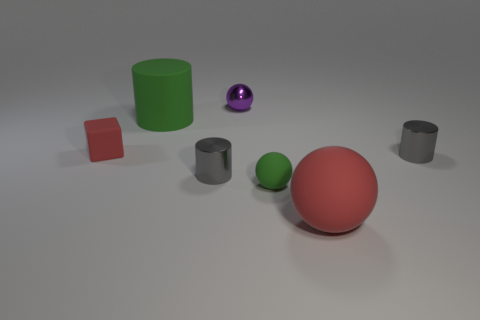Add 1 blocks. How many objects exist? 8 Subtract 2 cylinders. How many cylinders are left? 1 Subtract all tiny shiny cylinders. How many cylinders are left? 1 Subtract all spheres. How many objects are left? 4 Add 5 large balls. How many large balls exist? 6 Subtract all gray cylinders. How many cylinders are left? 1 Subtract 0 green blocks. How many objects are left? 7 Subtract all gray cubes. Subtract all cyan cylinders. How many cubes are left? 1 Subtract all purple spheres. How many cyan blocks are left? 0 Subtract all matte things. Subtract all small yellow matte cylinders. How many objects are left? 3 